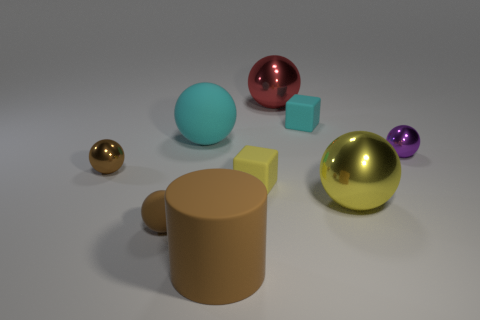Add 1 big red metal things. How many objects exist? 10 Subtract all cylinders. How many objects are left? 8 Subtract all cyan cubes. How many cubes are left? 1 Subtract all large matte spheres. How many spheres are left? 5 Subtract 1 brown cylinders. How many objects are left? 8 Subtract 1 cubes. How many cubes are left? 1 Subtract all cyan cylinders. Subtract all gray cubes. How many cylinders are left? 1 Subtract all blue cylinders. How many green spheres are left? 0 Subtract all tiny yellow rubber objects. Subtract all big cyan balls. How many objects are left? 7 Add 6 tiny rubber objects. How many tiny rubber objects are left? 9 